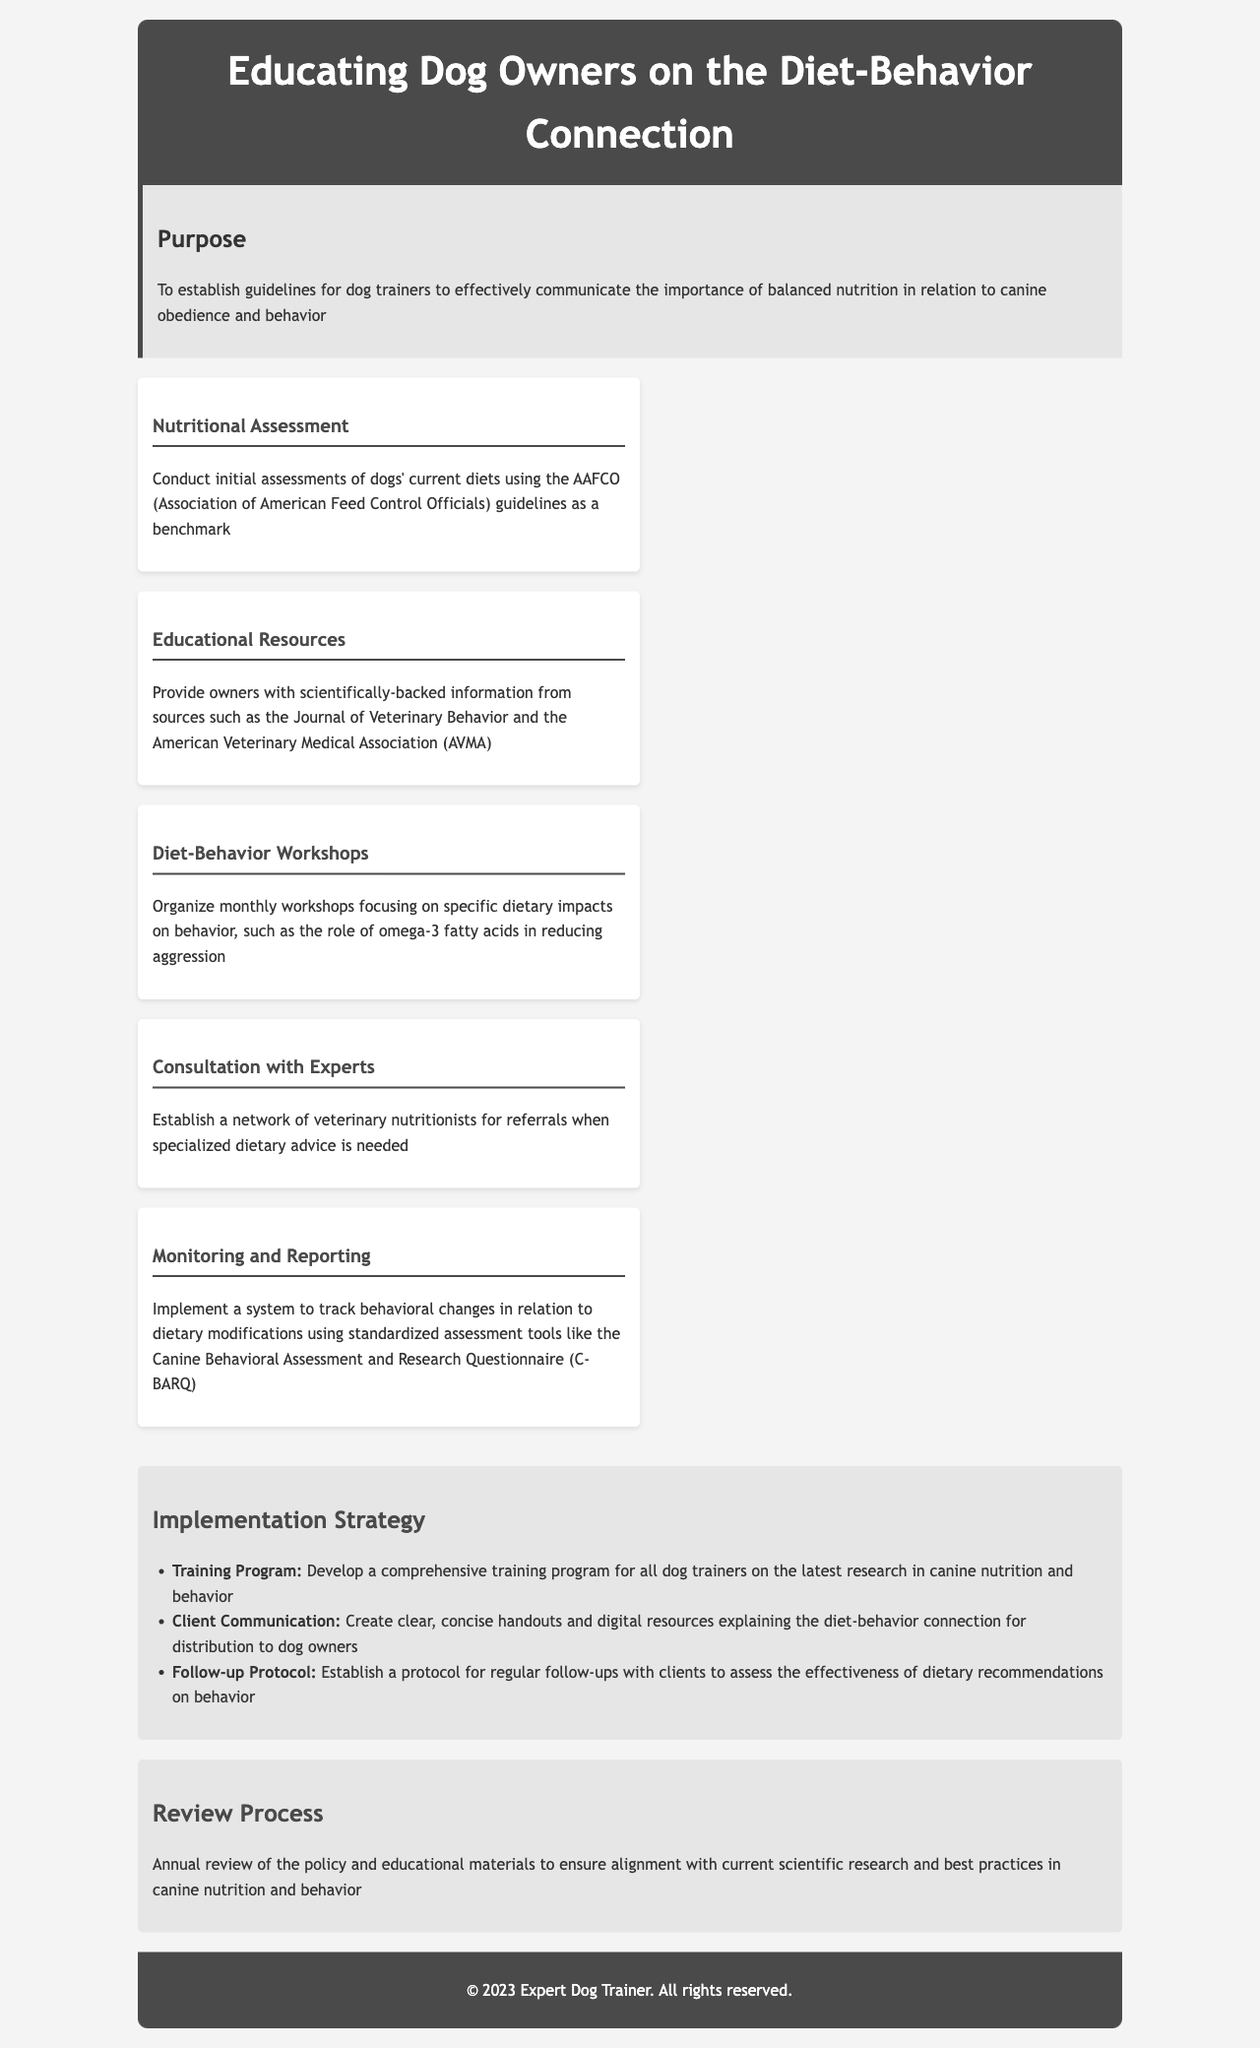What is the purpose of the policy? The purpose is to establish guidelines for dog trainers to effectively communicate the importance of balanced nutrition in relation to canine obedience and behavior.
Answer: To establish guidelines for dog trainers to effectively communicate the importance of balanced nutrition in relation to canine obedience and behavior What guideline is used for nutritional assessment? The nutritional assessment uses the AAFCO (Association of American Feed Control Officials) guidelines as a benchmark.
Answer: AAFCO (Association of American Feed Control Officials) guidelines What is one key point mentioned regarding education? One key point is to provide owners with scientifically-backed information from sources like the Journal of Veterinary Behavior.
Answer: Scientifically-backed information from sources like the Journal of Veterinary Behavior How often are diet-behavior workshops organized? Workshops focusing on dietary impacts on behavior are organized monthly.
Answer: Monthly What is one implementation strategy mentioned? One implementation strategy is to develop a comprehensive training program for all dog trainers on the latest research in canine nutrition and behavior.
Answer: Develop a comprehensive training program for all dog trainers on the latest research in canine nutrition and behavior When is the policy and educational materials scheduled for review? The policy and educational materials are subject to an annual review.
Answer: Annual review 